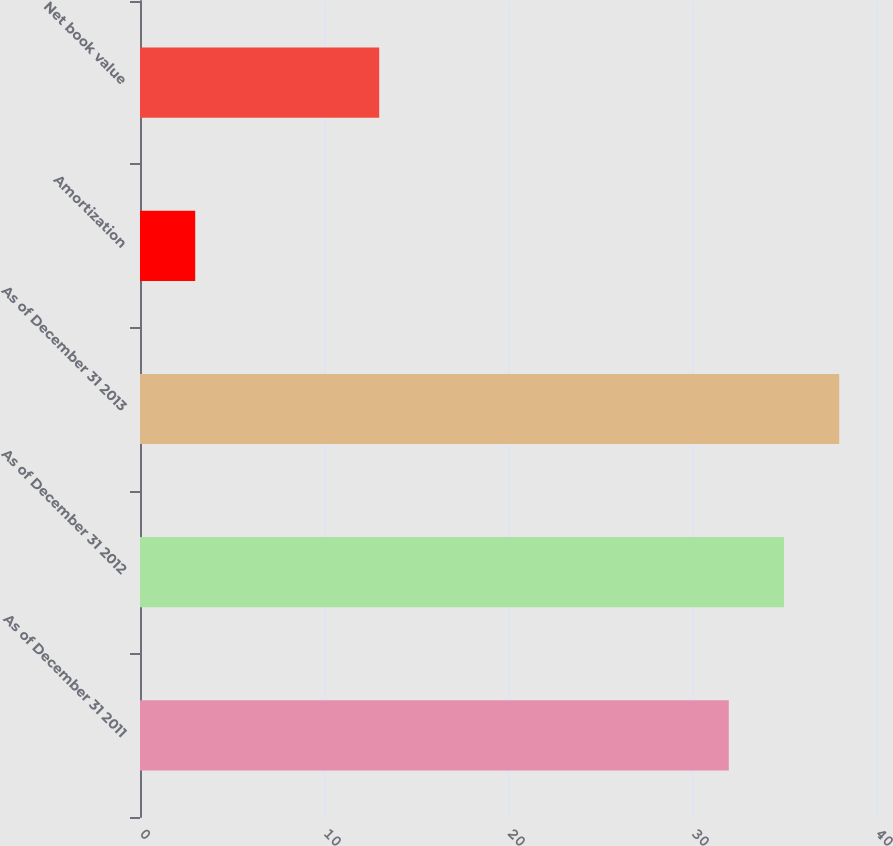Convert chart. <chart><loc_0><loc_0><loc_500><loc_500><bar_chart><fcel>As of December 31 2011<fcel>As of December 31 2012<fcel>As of December 31 2013<fcel>Amortization<fcel>Net book value<nl><fcel>32<fcel>35<fcel>38<fcel>3<fcel>13<nl></chart> 